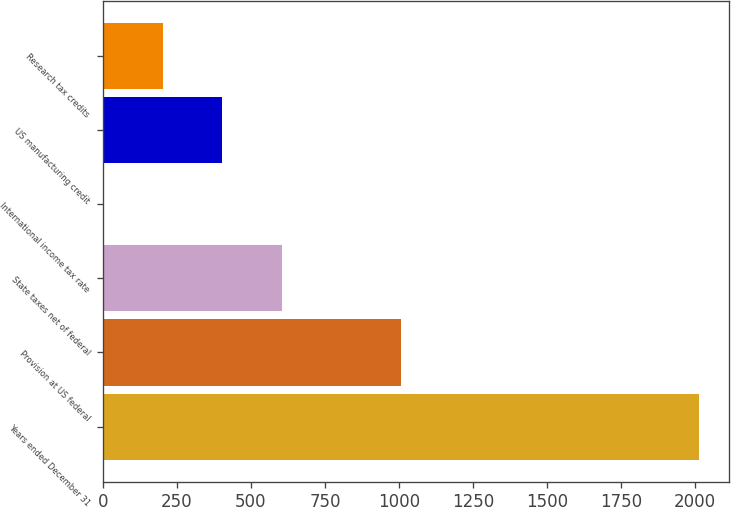Convert chart to OTSL. <chart><loc_0><loc_0><loc_500><loc_500><bar_chart><fcel>Years ended December 31<fcel>Provision at US federal<fcel>State taxes net of federal<fcel>International income tax rate<fcel>US manufacturing credit<fcel>Research tax credits<nl><fcel>2014<fcel>1007.2<fcel>604.48<fcel>0.4<fcel>403.12<fcel>201.76<nl></chart> 